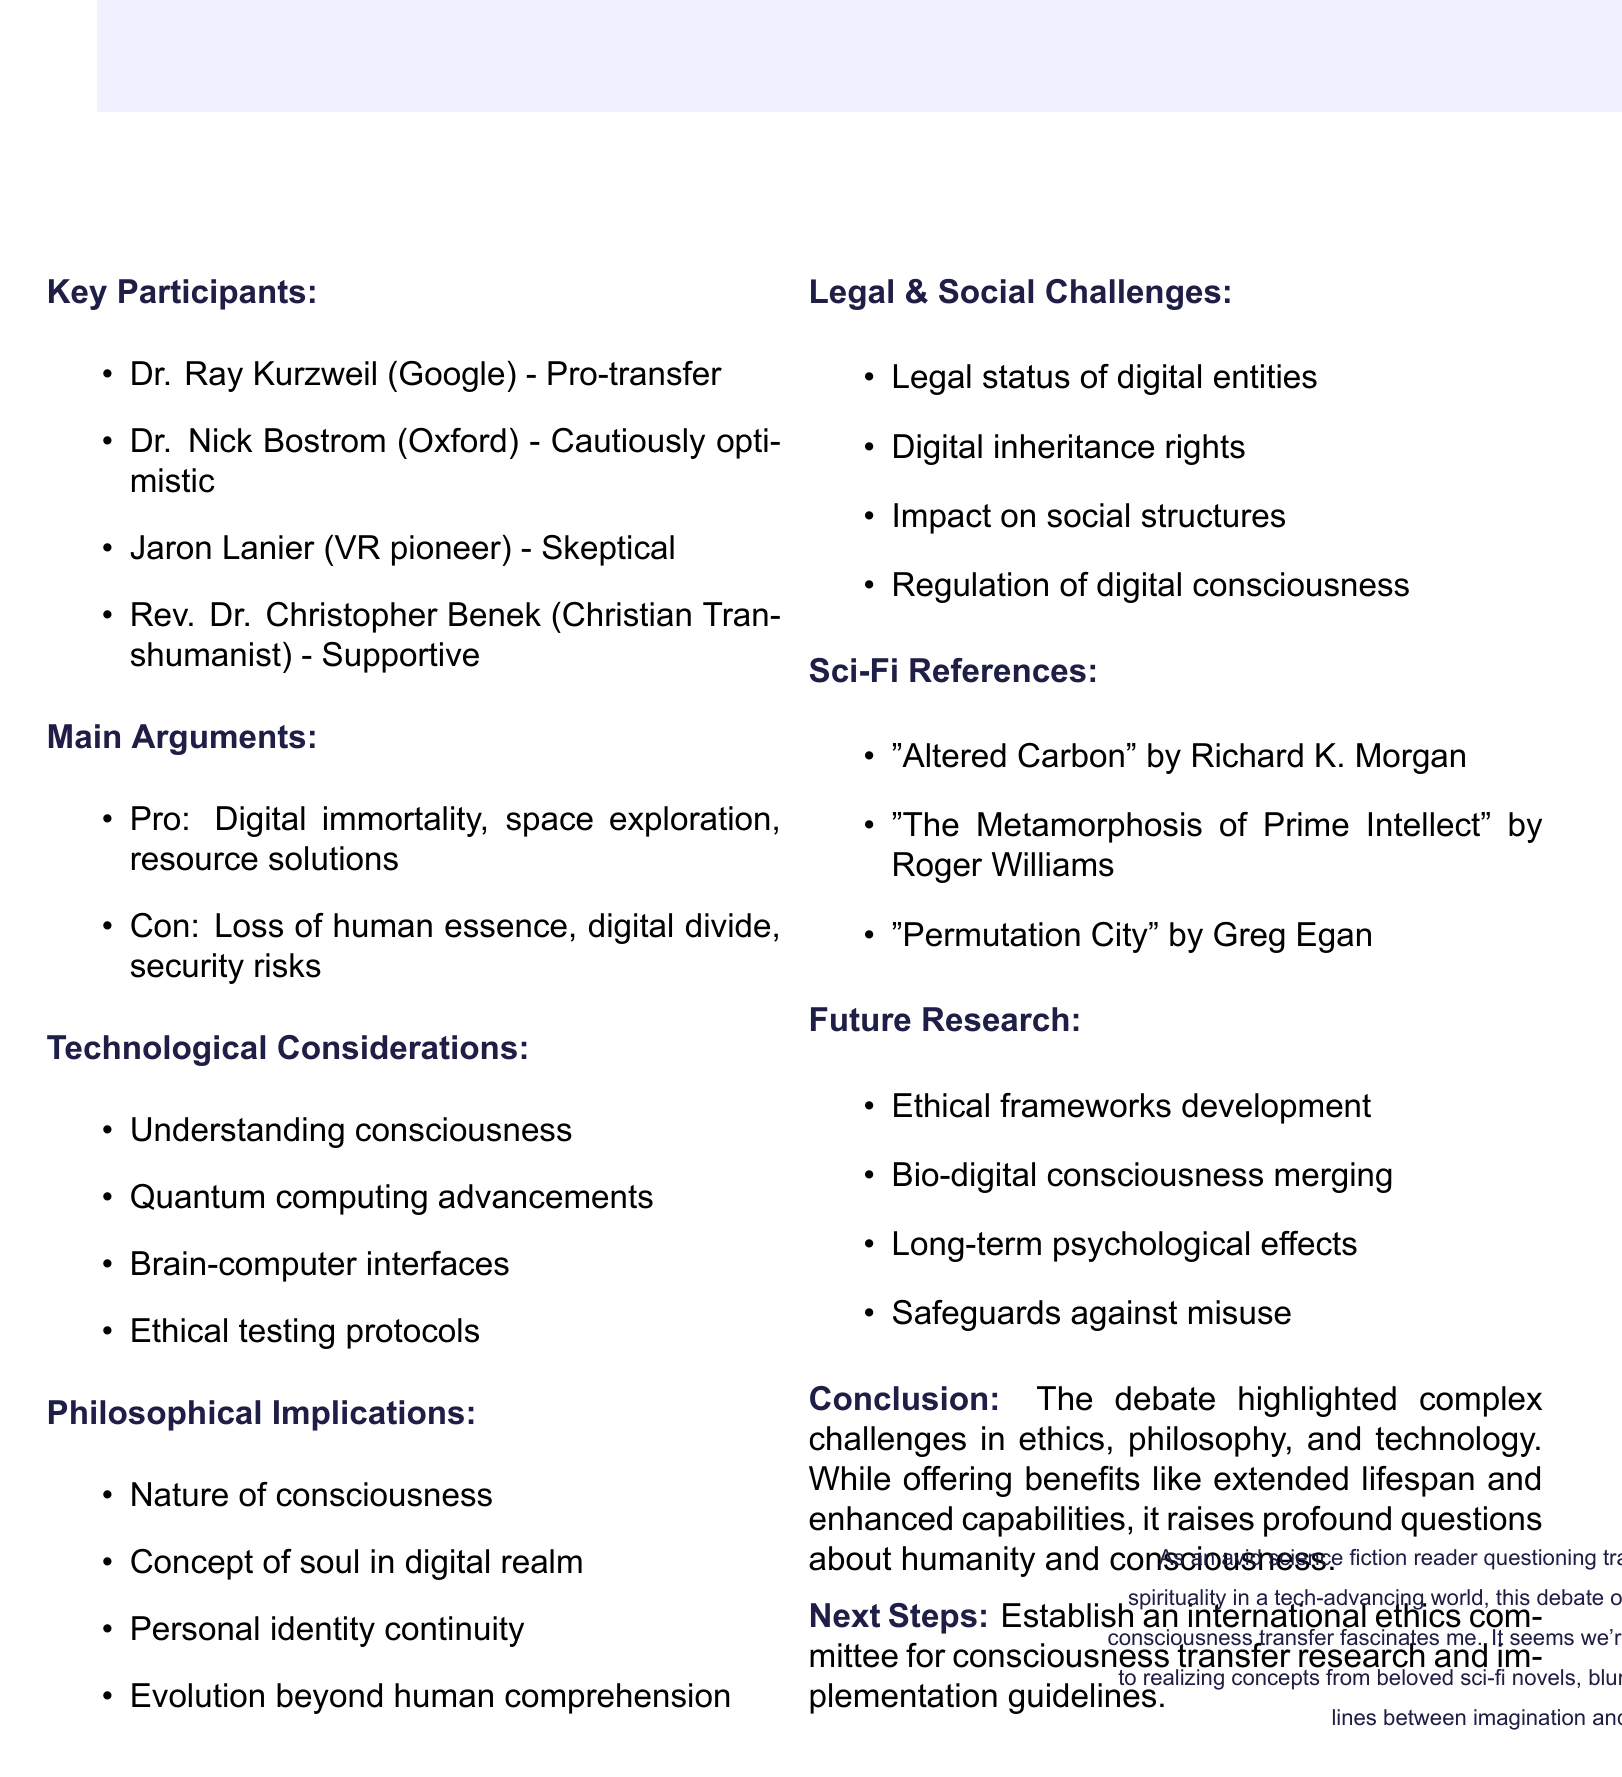What is the date of the meeting? The date of the meeting is specified in the document as May 15, 2023.
Answer: May 15, 2023 Who moderated the debate? The document indicates that the moderator of the debate is Dr. Eliza Turing.
Answer: Dr. Eliza Turing What is one pro argument discussed in the meeting? The document lists several pro arguments, one of which is digital immortality could lead to unprecedented human knowledge accumulation.
Answer: Digital immortality What is the stance of Jaron Lanier? Jaron Lanier's stance on consciousness transfer is mentioned in the document as skeptical.
Answer: Skeptical What ethical consideration is highlighted regarding digital consciousness? The document mentions the potential for digital manipulation or hacking of consciousness as a serious ethical consideration.
Answer: Digital manipulation or hacking What is the legal challenge mentioned in the document? The document cites defining legal status and rights of digital entities as a key legal challenge discussed.
Answer: Legal status and rights of digital entities Name a science fiction reference included in the memo. The document lists "Altered Carbon" by Richard K. Morgan as one of the referenced science fiction works.
Answer: Altered Carbon What is the conclusion of the debate regarding consciousness transfer? The conclusion summarizes that the debate highlighted complex challenges in ethics, philosophy, and technology.
Answer: Complex challenges in ethics, philosophy, and technology 